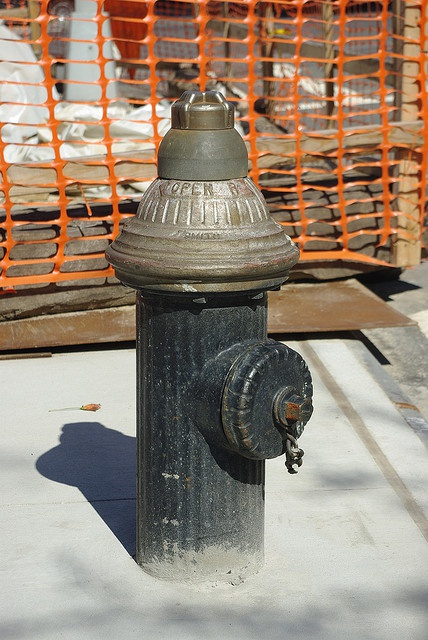Describe the objects in this image and their specific colors. I can see a fire hydrant in black, gray, and darkgray tones in this image. 